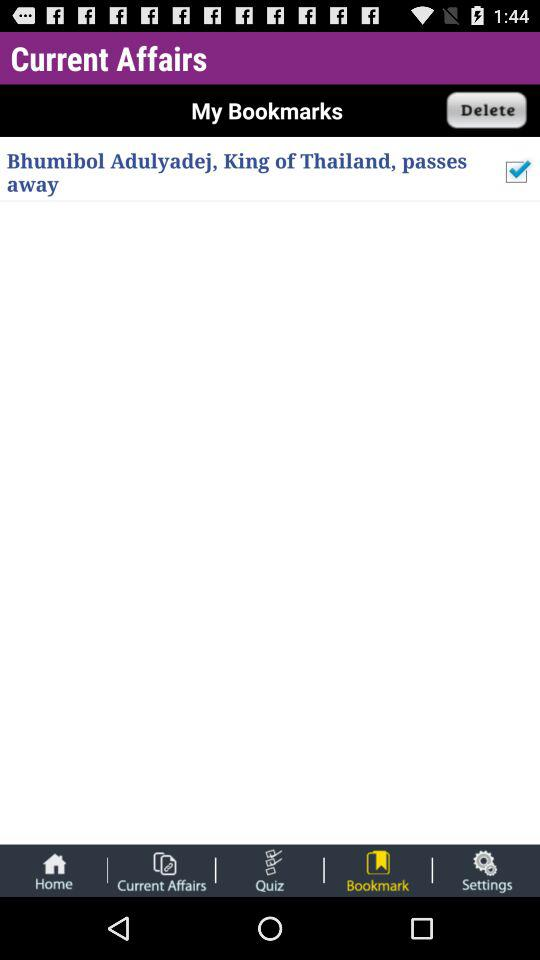Which option is selected for "Current Affairs"? The selected option is "Bookmark". 